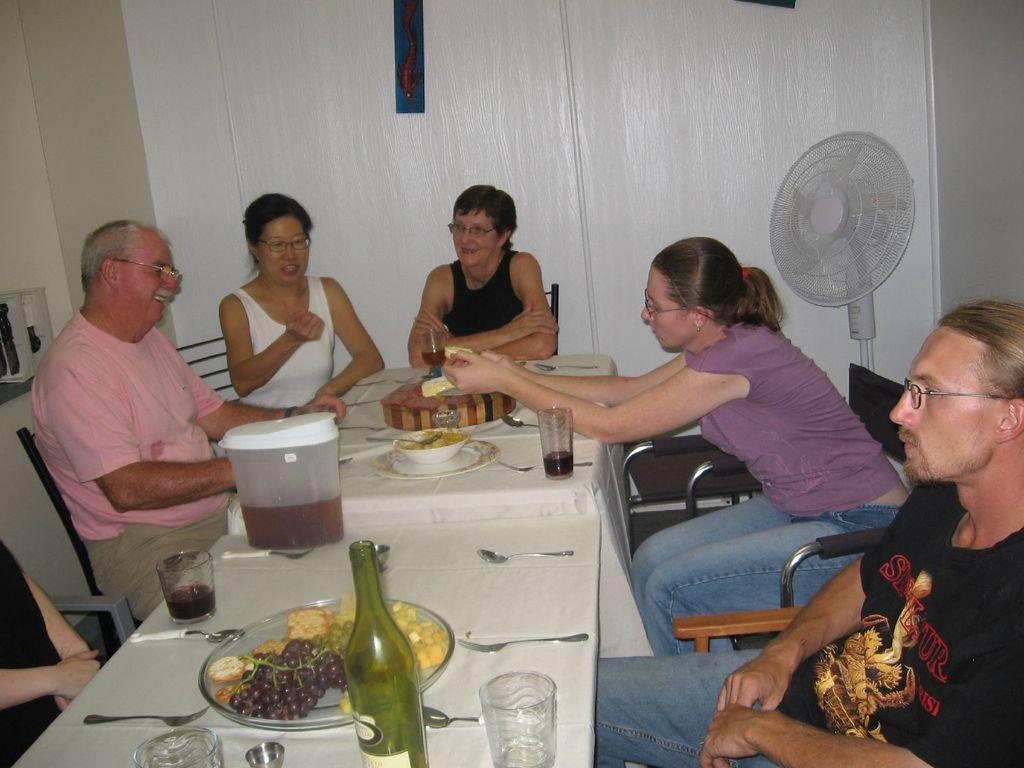What are the people in the image doing? The people in the image are sitting around a dining table. What can be seen on the dining table? There are glasses, spoons, and food items on the dining table. What might be used for drinking in the image? The glasses on the dining table might be used for drinking. What is visible in the background of the image? There is a fan visible in the background of the image. Reasoning: Let' Let's think step by step in order to produce the conversation. We start by identifying the main activity in the image, which is people sitting around a dining table. Then, we describe the objects on the table, including glasses, spoons, and food items. We also mention the presence of a fan in the background. Each question is designed to elicit a specific detail about the image that is known from the provided facts. Absurd Question/Answer: What type of root is growing out of the dining table in the image? There is no root growing out of the dining table in the image. What scientific theory is being discussed by the people sitting at the table? The image does not provide any information about a scientific theory being discussed by the people at the table. What type of bag is hanging on the wall behind the people in the image? There is no bag hanging on the wall behind the people in the image. 